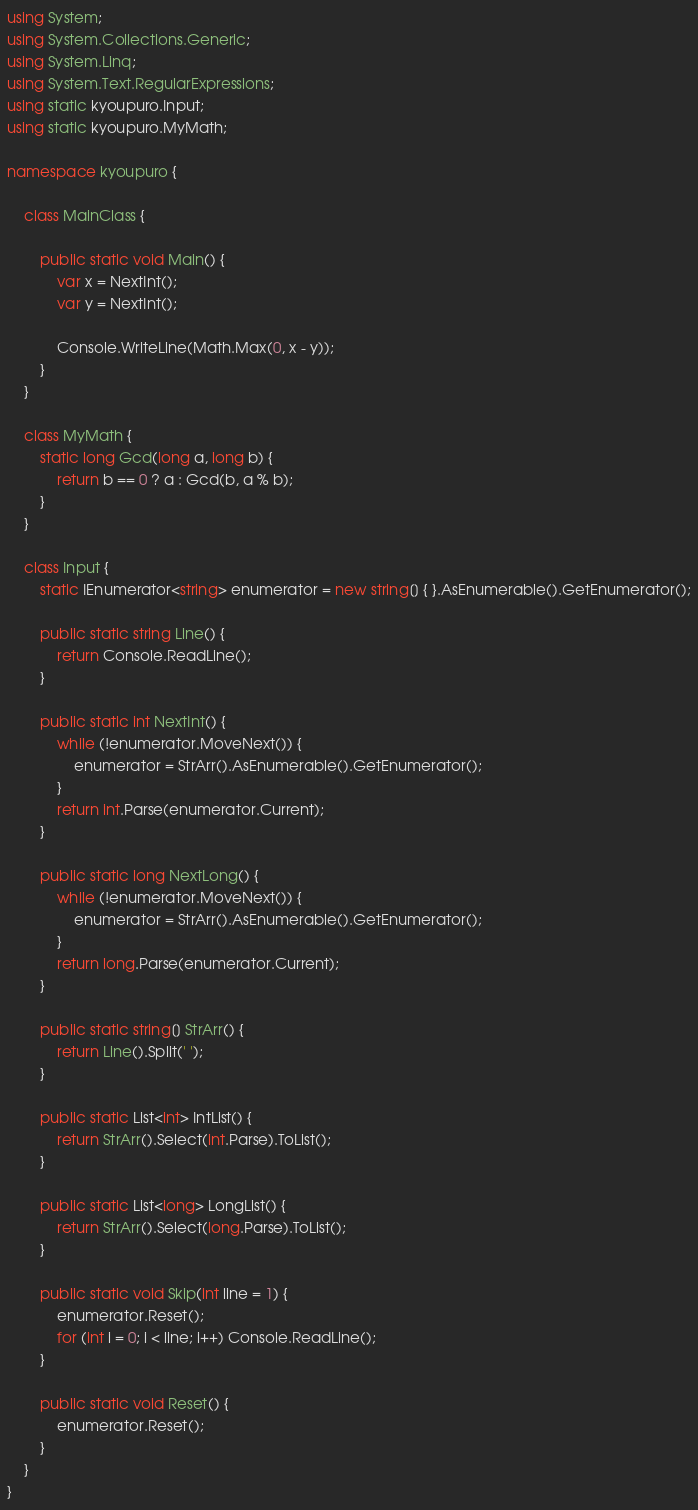<code> <loc_0><loc_0><loc_500><loc_500><_C#_>using System;
using System.Collections.Generic;
using System.Linq;
using System.Text.RegularExpressions;
using static kyoupuro.Input;
using static kyoupuro.MyMath;

namespace kyoupuro {

    class MainClass {

        public static void Main() {
            var x = NextInt();
            var y = NextInt();

            Console.WriteLine(Math.Max(0, x - y));
        }
    }

    class MyMath {
        static long Gcd(long a, long b) {
            return b == 0 ? a : Gcd(b, a % b);
        }
    }

    class Input {
        static IEnumerator<string> enumerator = new string[] { }.AsEnumerable().GetEnumerator();

        public static string Line() {
            return Console.ReadLine();
        }

        public static int NextInt() {
            while (!enumerator.MoveNext()) {
                enumerator = StrArr().AsEnumerable().GetEnumerator();
            }
            return int.Parse(enumerator.Current);
        }

        public static long NextLong() {
            while (!enumerator.MoveNext()) {
                enumerator = StrArr().AsEnumerable().GetEnumerator();
            }
            return long.Parse(enumerator.Current);
        }

        public static string[] StrArr() {
            return Line().Split(' ');
        }

        public static List<int> IntList() {
            return StrArr().Select(int.Parse).ToList();
        }

        public static List<long> LongList() {
            return StrArr().Select(long.Parse).ToList();
        }

        public static void Skip(int line = 1) {
            enumerator.Reset();
            for (int i = 0; i < line; i++) Console.ReadLine();
        }

        public static void Reset() {
            enumerator.Reset();
        }
    }
}</code> 